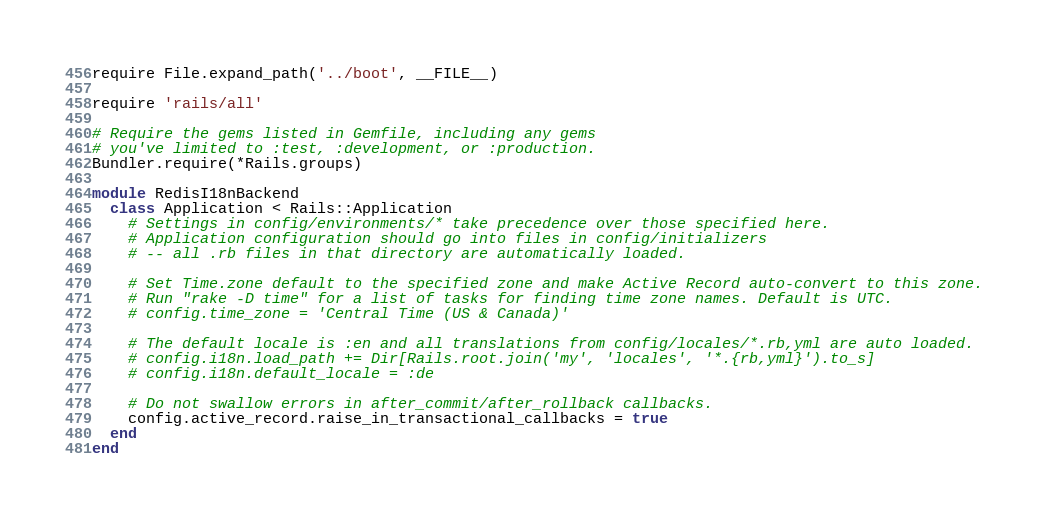Convert code to text. <code><loc_0><loc_0><loc_500><loc_500><_Ruby_>require File.expand_path('../boot', __FILE__)

require 'rails/all'

# Require the gems listed in Gemfile, including any gems
# you've limited to :test, :development, or :production.
Bundler.require(*Rails.groups)

module RedisI18nBackend
  class Application < Rails::Application
    # Settings in config/environments/* take precedence over those specified here.
    # Application configuration should go into files in config/initializers
    # -- all .rb files in that directory are automatically loaded.

    # Set Time.zone default to the specified zone and make Active Record auto-convert to this zone.
    # Run "rake -D time" for a list of tasks for finding time zone names. Default is UTC.
    # config.time_zone = 'Central Time (US & Canada)'

    # The default locale is :en and all translations from config/locales/*.rb,yml are auto loaded.
    # config.i18n.load_path += Dir[Rails.root.join('my', 'locales', '*.{rb,yml}').to_s]
    # config.i18n.default_locale = :de

    # Do not swallow errors in after_commit/after_rollback callbacks.
    config.active_record.raise_in_transactional_callbacks = true
  end
end
</code> 